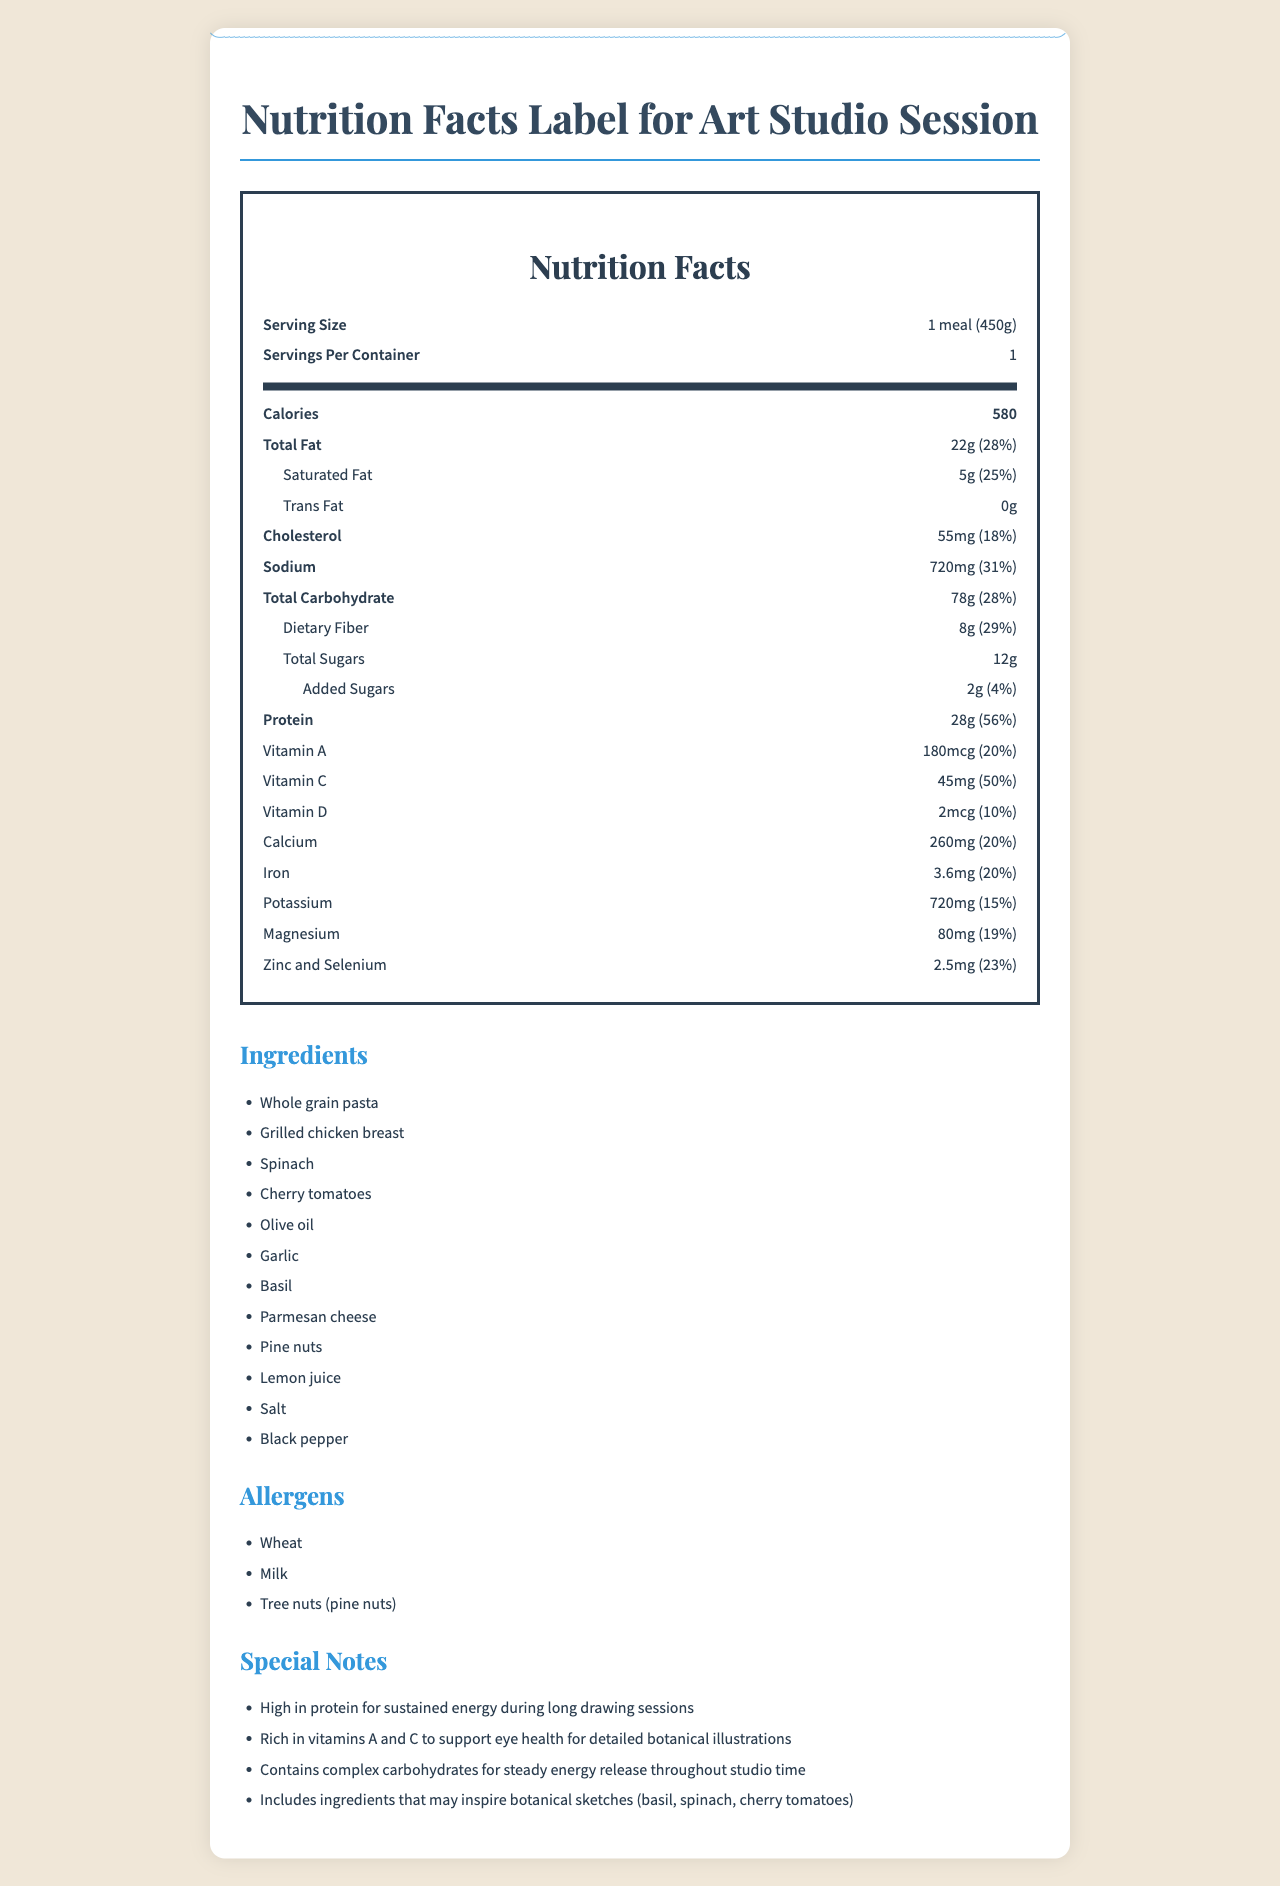what is the serving size of the meal? The serving size is explicitly stated as "1 meal (450g)" in the document.
Answer: 1 meal (450g) how many calories are in one serving of this meal? The document states the number of calories as 580.
Answer: 580 what is the cholesterol content of the meal, and what percentage of the daily value does it represent? The document lists the cholesterol content as 55mg and the daily value percentage as 18%.
Answer: 55mg (18%) name three main ingredients in this meal. The ingredients listed include Whole grain pasta, Grilled chicken breast, Spinach, among others.
Answer: Whole grain pasta, Grilled chicken breast, Spinach which nutrient has the highest percentage of daily value? The document lists Protein with a daily value of 56%, which is the highest among all the listed nutrients.
Answer: Protein (56%) which of the following meals is an allergen? A. Broccoli B. Pine nuts C. Grapes The allergens listed in the document include Tree nuts (pine nuts).
Answer: B how much vitamin C does this meal provide? A. 20mg B. 30mg C. 45mg D. 50mg The document states the meal provides 45mg of vitamin C.
Answer: C is the meal high in protein? The document states the protein content as 28g with a daily value of 56%, indicating it is high in protein.
Answer: Yes describe the nutritional benefits mentioned in the document for art students. The special notes section highlights these nutritional benefits, making them advantageous for art students.
Answer: High in protein for sustained energy, rich in vitamins A and C for eye health, contains complex carbohydrates for steady energy, and includes ingredients that inspire botanical sketches. which ingredient supports eye health? The document mentions vitamin A and C, which are commonly found in spinach and are known to support eye health.
Answer: Spinach what is the total carbohydrate amount and its daily value percentage in this meal? The document states the total carbohydrate content as 78g with a daily value percentage of 28%.
Answer: 78g (28%) which nutrient information is missing from this meal label? The document doesn't provide details on every possible nutrient. However, determining a specific missing nutrient cannot be gleaned from the existing information.
Answer: Not enough information how many grams of saturated fat are there in the meal? The document states that there are 5 grams of saturated fat.
Answer: 5g is vitamin D present in this meal? If yes, how much? The document lists vitamin D as present with an amount of 2 mcg and a daily value of 10%.
Answer: Yes, 2 mcg (10%) does this meal contain any trans fats? The document shows 0 grams of trans fat.
Answer: No what is the main purpose of this document? The document focuses on detailing the nutritional facts, ingredients, allergens, and special notes relevant to the consumption of the meal by art students. It emphasizes energy sustainability and elements beneficial to drawing practices.
Answer: To provide nutritional information of a meal recommended for art students. 